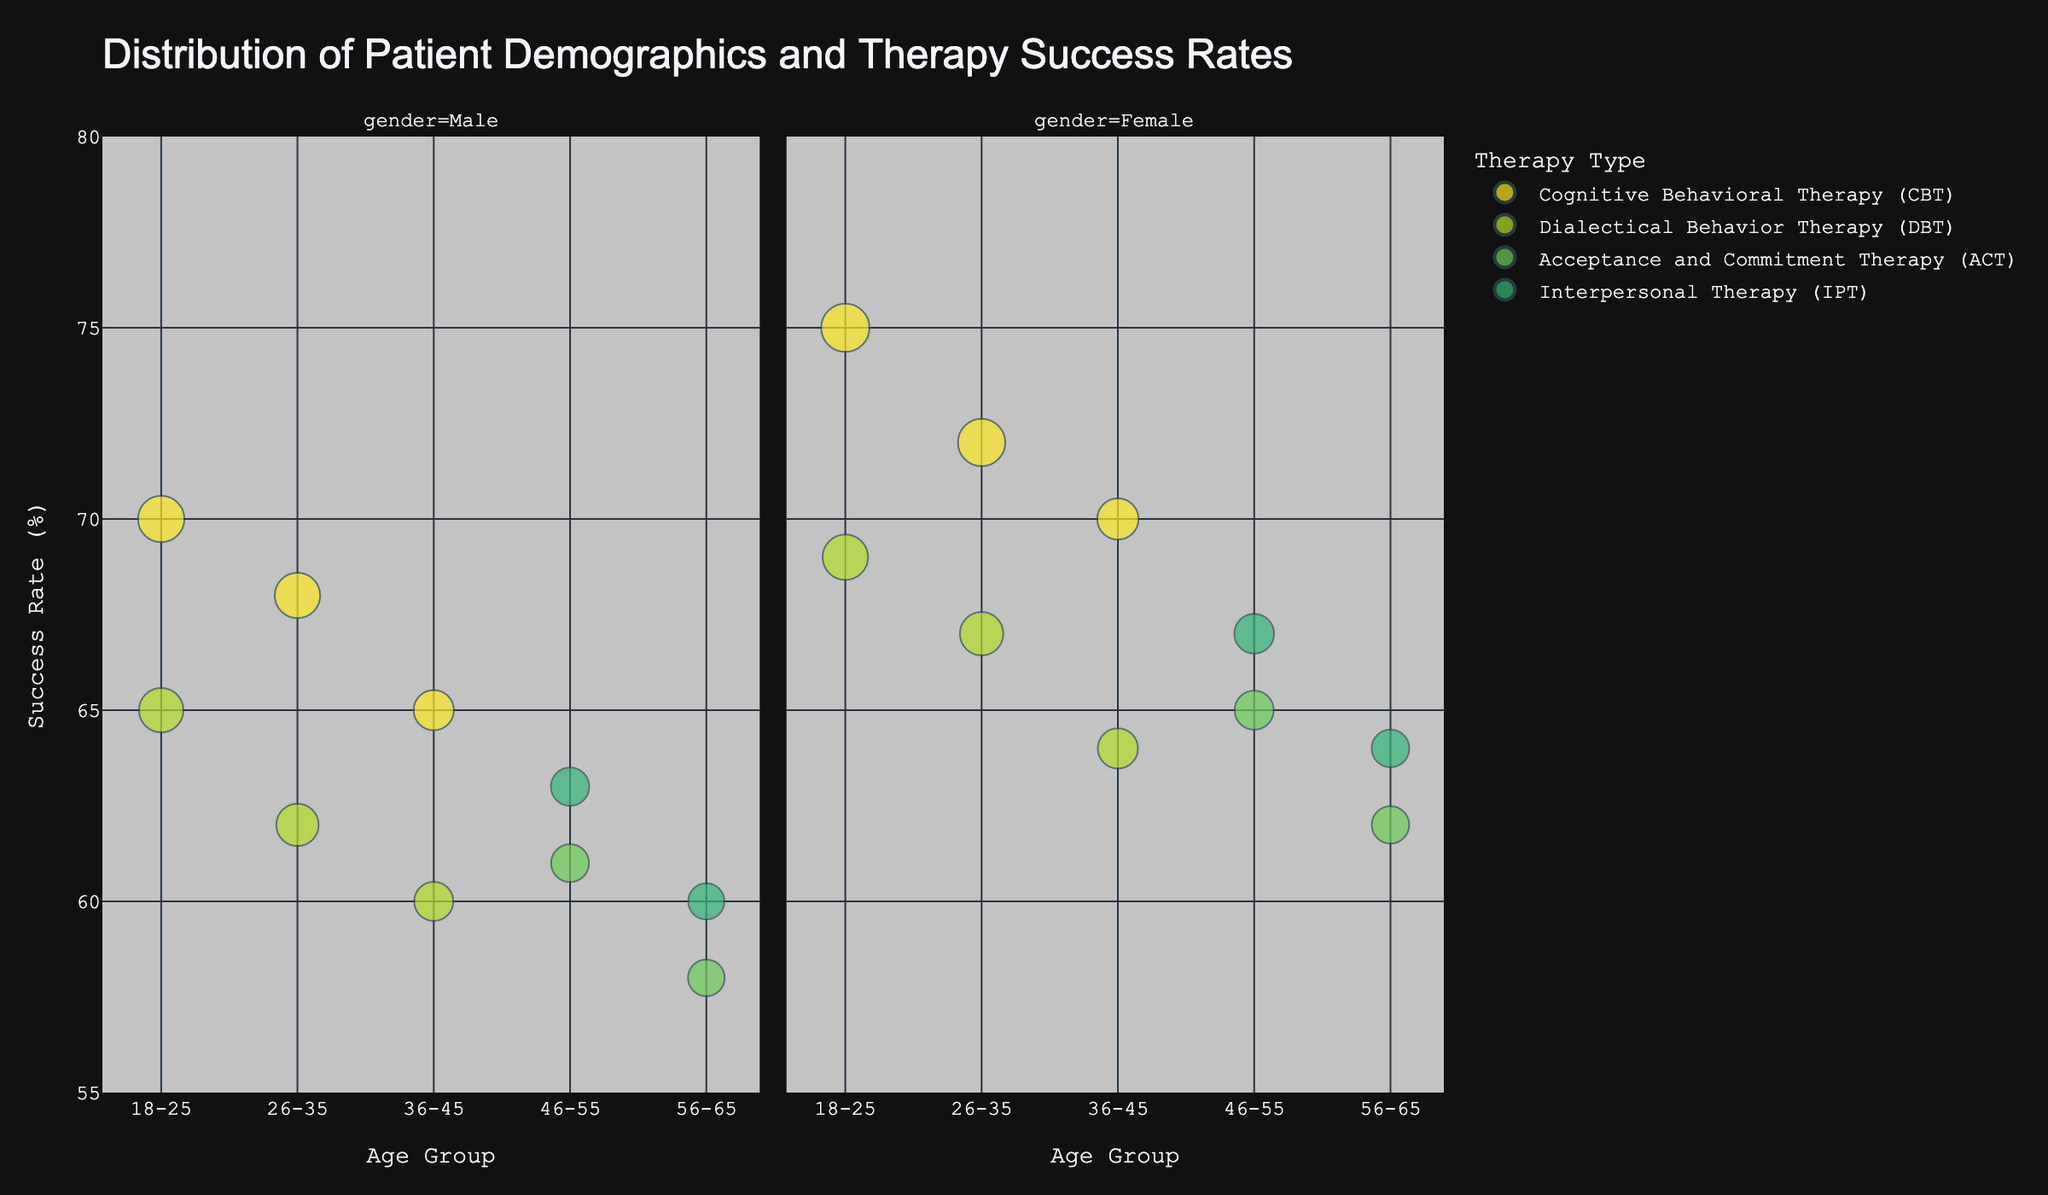what is the title of the figure? The title is prominently displayed at the top of the figure. "Distribution of Patient Demographics and Therapy Success Rates" summarizes what the chart is about.
Answer: Distribution of Patient Demographics and Therapy Success Rates how many age groups are presented in the chart? By examining the x-axis, we can see the distinct age groups as categories. The age groups are "18-25", "26-35", "36-45", "46-55", and "56-65".
Answer: 5 which therapy type has the highest success rate among the "18-25" age group? By looking at the "18-25" age group on the x-axis and checking for the highest position on the y-axis within this group, we find that Cognitive Behavioral Therapy (CBT) has the highest success rate with 75%.
Answer: Cognitive Behavioral Therapy (CBT) what is the difference in success rates between males and females in the "26-35" age group for Dialectical Behavior Therapy (DBT)? Locate the bubbles for DBT in the "26-35" age group for both males and females. The success rates are 62% for males and 67% for females. The difference is 67% - 62%.
Answer: 5% which gender has the higher number of patients receiving Interpersonal Therapy (IPT) in the "46-55" age group? Check the bubbles for IPT in the "46-55" age group on both facet columns (male and female). The size of the bubbles (number of patients) shows that females have 88 patients and males have 82 patients.
Answer: Female what is the average success rate for Acceptance and Commitment Therapy (ACT) across all age groups? List the success rates for ACT: 61, 65, 58, and 62. Sum these rates and divide by the number of age groups (61 + 65 + 58 + 62) / 4. The answer is (246 / 4).
Answer: 61.5% which therapy type has the greatest number of patients in the "36-45" age group? Check the sizes of the bubbles in the "36-45" age group and compare their numbers. The largest bubble corresponds to Cognitive Behavioral Therapy (CBT) with 90 + 95 = 185 patients.
Answer: Cognitive Behavioral Therapy (CBT) among females, which age group-therapy combination has the lowest success rate? Look across the female facet column and find the lowest bubble on the y-axis. The lowest success rate (60%) is found with Dialectical Behavior Therapy (DBT) in the "36-45" age group.
Answer: 36-45, Dialectical Behavior Therapy (DBT) is the success rate higher for males in "56-65" receiving ACT or IPT? Compare the y-axis positions of bubbles for males in the "56-65" age group for ACT and IPT therapies. Males receiving IPT have a success rate of 60% while those receiving ACT have 58%.
Answer: IPT 